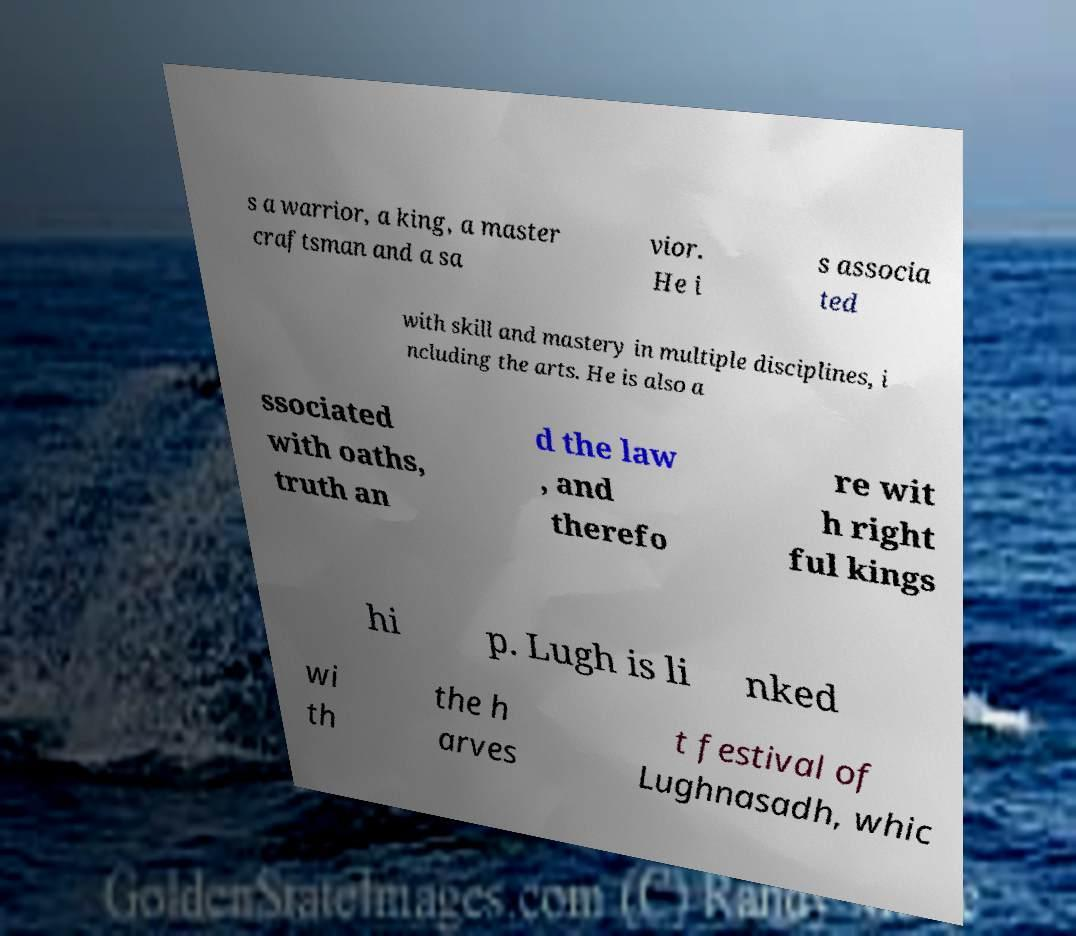Please identify and transcribe the text found in this image. s a warrior, a king, a master craftsman and a sa vior. He i s associa ted with skill and mastery in multiple disciplines, i ncluding the arts. He is also a ssociated with oaths, truth an d the law , and therefo re wit h right ful kings hi p. Lugh is li nked wi th the h arves t festival of Lughnasadh, whic 